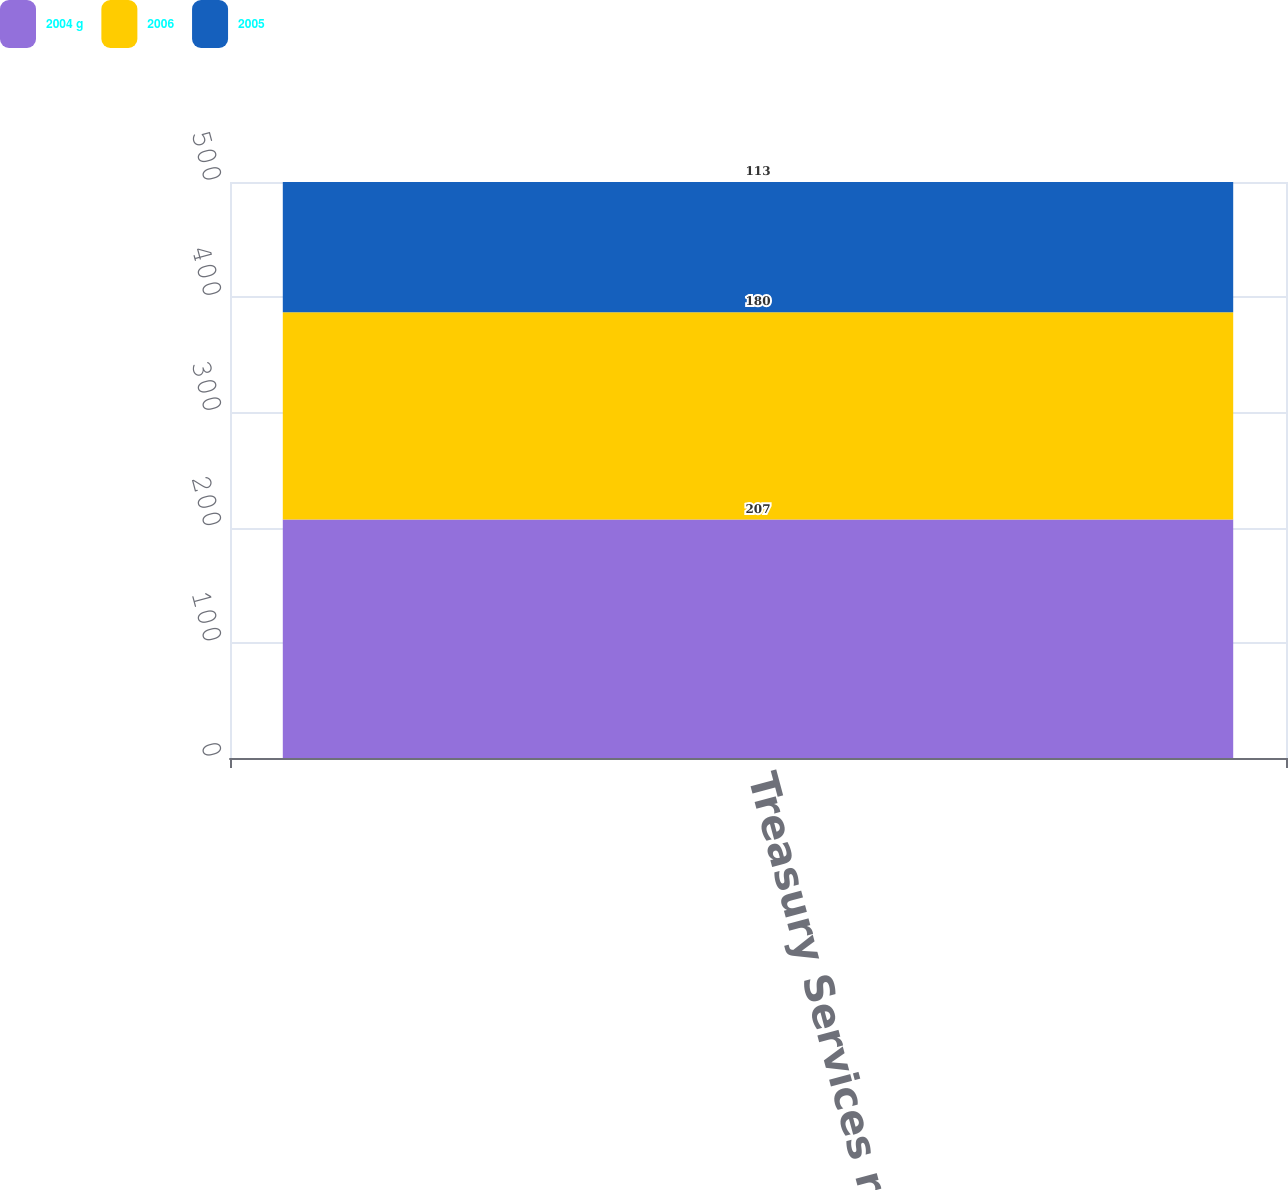Convert chart to OTSL. <chart><loc_0><loc_0><loc_500><loc_500><stacked_bar_chart><ecel><fcel>Treasury Services revenue<nl><fcel>2004 g<fcel>207<nl><fcel>2006<fcel>180<nl><fcel>2005<fcel>113<nl></chart> 